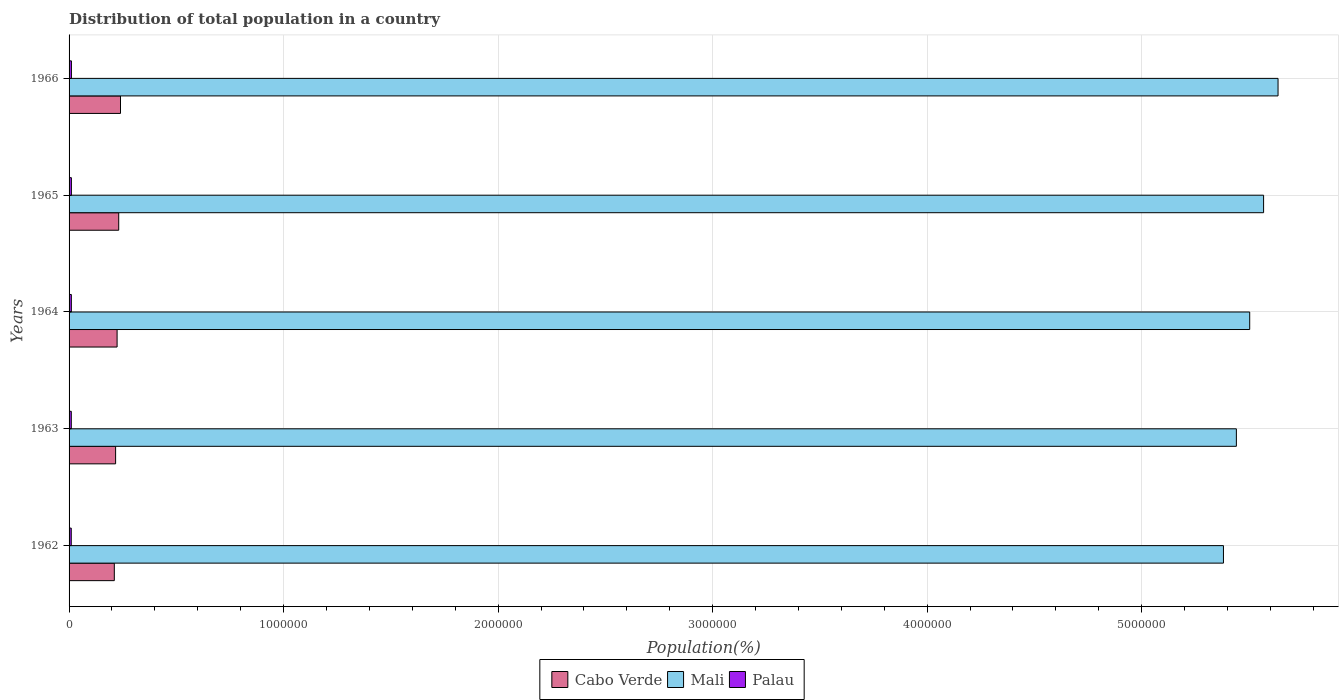How many different coloured bars are there?
Provide a succinct answer. 3. How many bars are there on the 4th tick from the top?
Provide a short and direct response. 3. What is the label of the 5th group of bars from the top?
Keep it short and to the point. 1962. What is the population of in Mali in 1964?
Ensure brevity in your answer.  5.50e+06. Across all years, what is the maximum population of in Mali?
Keep it short and to the point. 5.64e+06. Across all years, what is the minimum population of in Mali?
Give a very brief answer. 5.38e+06. In which year was the population of in Cabo Verde maximum?
Offer a terse response. 1966. In which year was the population of in Mali minimum?
Give a very brief answer. 1962. What is the total population of in Cabo Verde in the graph?
Offer a terse response. 1.12e+06. What is the difference between the population of in Mali in 1963 and that in 1965?
Give a very brief answer. -1.27e+05. What is the difference between the population of in Cabo Verde in 1964 and the population of in Mali in 1965?
Make the answer very short. -5.34e+06. What is the average population of in Cabo Verde per year?
Offer a very short reply. 2.25e+05. In the year 1964, what is the difference between the population of in Mali and population of in Palau?
Provide a short and direct response. 5.49e+06. What is the ratio of the population of in Cabo Verde in 1964 to that in 1965?
Your answer should be very brief. 0.97. What is the difference between the highest and the second highest population of in Cabo Verde?
Ensure brevity in your answer.  8338. What is the difference between the highest and the lowest population of in Palau?
Ensure brevity in your answer.  795. In how many years, is the population of in Palau greater than the average population of in Palau taken over all years?
Your answer should be very brief. 3. What does the 3rd bar from the top in 1965 represents?
Your response must be concise. Cabo Verde. What does the 3rd bar from the bottom in 1964 represents?
Your answer should be very brief. Palau. Are all the bars in the graph horizontal?
Your answer should be compact. Yes. What is the difference between two consecutive major ticks on the X-axis?
Make the answer very short. 1.00e+06. Are the values on the major ticks of X-axis written in scientific E-notation?
Make the answer very short. No. Does the graph contain grids?
Provide a short and direct response. Yes. Where does the legend appear in the graph?
Make the answer very short. Bottom center. How are the legend labels stacked?
Your answer should be very brief. Horizontal. What is the title of the graph?
Your response must be concise. Distribution of total population in a country. What is the label or title of the X-axis?
Provide a succinct answer. Population(%). What is the label or title of the Y-axis?
Your response must be concise. Years. What is the Population(%) of Cabo Verde in 1962?
Your answer should be very brief. 2.11e+05. What is the Population(%) of Mali in 1962?
Your response must be concise. 5.38e+06. What is the Population(%) in Palau in 1962?
Provide a short and direct response. 1.02e+04. What is the Population(%) in Cabo Verde in 1963?
Keep it short and to the point. 2.17e+05. What is the Population(%) in Mali in 1963?
Make the answer very short. 5.44e+06. What is the Population(%) of Palau in 1963?
Offer a terse response. 1.04e+04. What is the Population(%) in Cabo Verde in 1964?
Ensure brevity in your answer.  2.24e+05. What is the Population(%) in Mali in 1964?
Keep it short and to the point. 5.50e+06. What is the Population(%) of Palau in 1964?
Your answer should be compact. 1.06e+04. What is the Population(%) in Cabo Verde in 1965?
Your answer should be very brief. 2.31e+05. What is the Population(%) in Mali in 1965?
Provide a succinct answer. 5.57e+06. What is the Population(%) in Palau in 1965?
Provide a succinct answer. 1.08e+04. What is the Population(%) of Cabo Verde in 1966?
Make the answer very short. 2.40e+05. What is the Population(%) of Mali in 1966?
Keep it short and to the point. 5.64e+06. What is the Population(%) of Palau in 1966?
Offer a very short reply. 1.09e+04. Across all years, what is the maximum Population(%) in Cabo Verde?
Offer a terse response. 2.40e+05. Across all years, what is the maximum Population(%) in Mali?
Keep it short and to the point. 5.64e+06. Across all years, what is the maximum Population(%) of Palau?
Make the answer very short. 1.09e+04. Across all years, what is the minimum Population(%) in Cabo Verde?
Provide a succinct answer. 2.11e+05. Across all years, what is the minimum Population(%) of Mali?
Provide a short and direct response. 5.38e+06. Across all years, what is the minimum Population(%) in Palau?
Provide a succinct answer. 1.02e+04. What is the total Population(%) in Cabo Verde in the graph?
Provide a succinct answer. 1.12e+06. What is the total Population(%) of Mali in the graph?
Keep it short and to the point. 2.75e+07. What is the total Population(%) in Palau in the graph?
Provide a short and direct response. 5.29e+04. What is the difference between the Population(%) in Cabo Verde in 1962 and that in 1963?
Make the answer very short. -6047. What is the difference between the Population(%) in Mali in 1962 and that in 1963?
Offer a very short reply. -6.02e+04. What is the difference between the Population(%) in Palau in 1962 and that in 1963?
Provide a succinct answer. -231. What is the difference between the Population(%) of Cabo Verde in 1962 and that in 1964?
Offer a very short reply. -1.30e+04. What is the difference between the Population(%) in Mali in 1962 and that in 1964?
Offer a very short reply. -1.22e+05. What is the difference between the Population(%) of Palau in 1962 and that in 1964?
Offer a terse response. -443. What is the difference between the Population(%) in Cabo Verde in 1962 and that in 1965?
Provide a short and direct response. -2.06e+04. What is the difference between the Population(%) of Mali in 1962 and that in 1965?
Ensure brevity in your answer.  -1.87e+05. What is the difference between the Population(%) of Palau in 1962 and that in 1965?
Your response must be concise. -632. What is the difference between the Population(%) of Cabo Verde in 1962 and that in 1966?
Offer a very short reply. -2.89e+04. What is the difference between the Population(%) in Mali in 1962 and that in 1966?
Make the answer very short. -2.54e+05. What is the difference between the Population(%) of Palau in 1962 and that in 1966?
Your answer should be compact. -795. What is the difference between the Population(%) in Cabo Verde in 1963 and that in 1964?
Provide a short and direct response. -6941. What is the difference between the Population(%) of Mali in 1963 and that in 1964?
Offer a very short reply. -6.21e+04. What is the difference between the Population(%) of Palau in 1963 and that in 1964?
Give a very brief answer. -212. What is the difference between the Population(%) in Cabo Verde in 1963 and that in 1965?
Keep it short and to the point. -1.45e+04. What is the difference between the Population(%) in Mali in 1963 and that in 1965?
Offer a terse response. -1.27e+05. What is the difference between the Population(%) in Palau in 1963 and that in 1965?
Offer a very short reply. -401. What is the difference between the Population(%) of Cabo Verde in 1963 and that in 1966?
Ensure brevity in your answer.  -2.29e+04. What is the difference between the Population(%) in Mali in 1963 and that in 1966?
Keep it short and to the point. -1.94e+05. What is the difference between the Population(%) of Palau in 1963 and that in 1966?
Your response must be concise. -564. What is the difference between the Population(%) of Cabo Verde in 1964 and that in 1965?
Give a very brief answer. -7573. What is the difference between the Population(%) in Mali in 1964 and that in 1965?
Provide a short and direct response. -6.47e+04. What is the difference between the Population(%) of Palau in 1964 and that in 1965?
Give a very brief answer. -189. What is the difference between the Population(%) of Cabo Verde in 1964 and that in 1966?
Offer a very short reply. -1.59e+04. What is the difference between the Population(%) of Mali in 1964 and that in 1966?
Give a very brief answer. -1.32e+05. What is the difference between the Population(%) in Palau in 1964 and that in 1966?
Ensure brevity in your answer.  -352. What is the difference between the Population(%) in Cabo Verde in 1965 and that in 1966?
Provide a succinct answer. -8338. What is the difference between the Population(%) in Mali in 1965 and that in 1966?
Your answer should be compact. -6.74e+04. What is the difference between the Population(%) in Palau in 1965 and that in 1966?
Ensure brevity in your answer.  -163. What is the difference between the Population(%) of Cabo Verde in 1962 and the Population(%) of Mali in 1963?
Your answer should be compact. -5.23e+06. What is the difference between the Population(%) in Cabo Verde in 1962 and the Population(%) in Palau in 1963?
Ensure brevity in your answer.  2.00e+05. What is the difference between the Population(%) of Mali in 1962 and the Population(%) of Palau in 1963?
Your answer should be very brief. 5.37e+06. What is the difference between the Population(%) in Cabo Verde in 1962 and the Population(%) in Mali in 1964?
Ensure brevity in your answer.  -5.29e+06. What is the difference between the Population(%) in Cabo Verde in 1962 and the Population(%) in Palau in 1964?
Your response must be concise. 2.00e+05. What is the difference between the Population(%) of Mali in 1962 and the Population(%) of Palau in 1964?
Your answer should be very brief. 5.37e+06. What is the difference between the Population(%) of Cabo Verde in 1962 and the Population(%) of Mali in 1965?
Offer a very short reply. -5.36e+06. What is the difference between the Population(%) in Cabo Verde in 1962 and the Population(%) in Palau in 1965?
Ensure brevity in your answer.  2.00e+05. What is the difference between the Population(%) in Mali in 1962 and the Population(%) in Palau in 1965?
Provide a short and direct response. 5.37e+06. What is the difference between the Population(%) in Cabo Verde in 1962 and the Population(%) in Mali in 1966?
Your response must be concise. -5.42e+06. What is the difference between the Population(%) of Cabo Verde in 1962 and the Population(%) of Palau in 1966?
Offer a very short reply. 2.00e+05. What is the difference between the Population(%) in Mali in 1962 and the Population(%) in Palau in 1966?
Give a very brief answer. 5.37e+06. What is the difference between the Population(%) in Cabo Verde in 1963 and the Population(%) in Mali in 1964?
Ensure brevity in your answer.  -5.29e+06. What is the difference between the Population(%) in Cabo Verde in 1963 and the Population(%) in Palau in 1964?
Offer a terse response. 2.06e+05. What is the difference between the Population(%) of Mali in 1963 and the Population(%) of Palau in 1964?
Keep it short and to the point. 5.43e+06. What is the difference between the Population(%) in Cabo Verde in 1963 and the Population(%) in Mali in 1965?
Your answer should be very brief. -5.35e+06. What is the difference between the Population(%) of Cabo Verde in 1963 and the Population(%) of Palau in 1965?
Give a very brief answer. 2.06e+05. What is the difference between the Population(%) in Mali in 1963 and the Population(%) in Palau in 1965?
Offer a terse response. 5.43e+06. What is the difference between the Population(%) in Cabo Verde in 1963 and the Population(%) in Mali in 1966?
Your answer should be compact. -5.42e+06. What is the difference between the Population(%) of Cabo Verde in 1963 and the Population(%) of Palau in 1966?
Provide a succinct answer. 2.06e+05. What is the difference between the Population(%) in Mali in 1963 and the Population(%) in Palau in 1966?
Keep it short and to the point. 5.43e+06. What is the difference between the Population(%) in Cabo Verde in 1964 and the Population(%) in Mali in 1965?
Keep it short and to the point. -5.34e+06. What is the difference between the Population(%) in Cabo Verde in 1964 and the Population(%) in Palau in 1965?
Offer a terse response. 2.13e+05. What is the difference between the Population(%) in Mali in 1964 and the Population(%) in Palau in 1965?
Give a very brief answer. 5.49e+06. What is the difference between the Population(%) in Cabo Verde in 1964 and the Population(%) in Mali in 1966?
Make the answer very short. -5.41e+06. What is the difference between the Population(%) in Cabo Verde in 1964 and the Population(%) in Palau in 1966?
Provide a short and direct response. 2.13e+05. What is the difference between the Population(%) of Mali in 1964 and the Population(%) of Palau in 1966?
Provide a succinct answer. 5.49e+06. What is the difference between the Population(%) in Cabo Verde in 1965 and the Population(%) in Mali in 1966?
Give a very brief answer. -5.40e+06. What is the difference between the Population(%) in Cabo Verde in 1965 and the Population(%) in Palau in 1966?
Your answer should be very brief. 2.20e+05. What is the difference between the Population(%) of Mali in 1965 and the Population(%) of Palau in 1966?
Ensure brevity in your answer.  5.56e+06. What is the average Population(%) in Cabo Verde per year?
Your answer should be very brief. 2.25e+05. What is the average Population(%) in Mali per year?
Provide a succinct answer. 5.51e+06. What is the average Population(%) in Palau per year?
Provide a short and direct response. 1.06e+04. In the year 1962, what is the difference between the Population(%) in Cabo Verde and Population(%) in Mali?
Your response must be concise. -5.17e+06. In the year 1962, what is the difference between the Population(%) in Cabo Verde and Population(%) in Palau?
Your response must be concise. 2.01e+05. In the year 1962, what is the difference between the Population(%) in Mali and Population(%) in Palau?
Your answer should be compact. 5.37e+06. In the year 1963, what is the difference between the Population(%) of Cabo Verde and Population(%) of Mali?
Your response must be concise. -5.22e+06. In the year 1963, what is the difference between the Population(%) of Cabo Verde and Population(%) of Palau?
Provide a short and direct response. 2.07e+05. In the year 1963, what is the difference between the Population(%) of Mali and Population(%) of Palau?
Your answer should be compact. 5.43e+06. In the year 1964, what is the difference between the Population(%) of Cabo Verde and Population(%) of Mali?
Keep it short and to the point. -5.28e+06. In the year 1964, what is the difference between the Population(%) of Cabo Verde and Population(%) of Palau?
Your answer should be very brief. 2.13e+05. In the year 1964, what is the difference between the Population(%) of Mali and Population(%) of Palau?
Give a very brief answer. 5.49e+06. In the year 1965, what is the difference between the Population(%) in Cabo Verde and Population(%) in Mali?
Provide a succinct answer. -5.34e+06. In the year 1965, what is the difference between the Population(%) of Cabo Verde and Population(%) of Palau?
Offer a terse response. 2.21e+05. In the year 1965, what is the difference between the Population(%) in Mali and Population(%) in Palau?
Provide a succinct answer. 5.56e+06. In the year 1966, what is the difference between the Population(%) in Cabo Verde and Population(%) in Mali?
Your answer should be compact. -5.40e+06. In the year 1966, what is the difference between the Population(%) in Cabo Verde and Population(%) in Palau?
Ensure brevity in your answer.  2.29e+05. In the year 1966, what is the difference between the Population(%) in Mali and Population(%) in Palau?
Keep it short and to the point. 5.62e+06. What is the ratio of the Population(%) of Cabo Verde in 1962 to that in 1963?
Your response must be concise. 0.97. What is the ratio of the Population(%) of Mali in 1962 to that in 1963?
Keep it short and to the point. 0.99. What is the ratio of the Population(%) of Palau in 1962 to that in 1963?
Give a very brief answer. 0.98. What is the ratio of the Population(%) in Cabo Verde in 1962 to that in 1964?
Make the answer very short. 0.94. What is the ratio of the Population(%) in Mali in 1962 to that in 1964?
Provide a succinct answer. 0.98. What is the ratio of the Population(%) in Palau in 1962 to that in 1964?
Give a very brief answer. 0.96. What is the ratio of the Population(%) of Cabo Verde in 1962 to that in 1965?
Make the answer very short. 0.91. What is the ratio of the Population(%) of Mali in 1962 to that in 1965?
Provide a succinct answer. 0.97. What is the ratio of the Population(%) in Palau in 1962 to that in 1965?
Your answer should be very brief. 0.94. What is the ratio of the Population(%) in Cabo Verde in 1962 to that in 1966?
Offer a terse response. 0.88. What is the ratio of the Population(%) of Mali in 1962 to that in 1966?
Provide a short and direct response. 0.95. What is the ratio of the Population(%) in Palau in 1962 to that in 1966?
Offer a terse response. 0.93. What is the ratio of the Population(%) of Mali in 1963 to that in 1964?
Provide a succinct answer. 0.99. What is the ratio of the Population(%) in Palau in 1963 to that in 1964?
Your answer should be compact. 0.98. What is the ratio of the Population(%) of Cabo Verde in 1963 to that in 1965?
Keep it short and to the point. 0.94. What is the ratio of the Population(%) in Mali in 1963 to that in 1965?
Your answer should be compact. 0.98. What is the ratio of the Population(%) of Palau in 1963 to that in 1965?
Keep it short and to the point. 0.96. What is the ratio of the Population(%) of Cabo Verde in 1963 to that in 1966?
Your response must be concise. 0.9. What is the ratio of the Population(%) in Mali in 1963 to that in 1966?
Your response must be concise. 0.97. What is the ratio of the Population(%) of Palau in 1963 to that in 1966?
Provide a short and direct response. 0.95. What is the ratio of the Population(%) in Cabo Verde in 1964 to that in 1965?
Provide a succinct answer. 0.97. What is the ratio of the Population(%) in Mali in 1964 to that in 1965?
Offer a terse response. 0.99. What is the ratio of the Population(%) in Palau in 1964 to that in 1965?
Your response must be concise. 0.98. What is the ratio of the Population(%) of Cabo Verde in 1964 to that in 1966?
Your response must be concise. 0.93. What is the ratio of the Population(%) in Mali in 1964 to that in 1966?
Your response must be concise. 0.98. What is the ratio of the Population(%) in Palau in 1964 to that in 1966?
Provide a succinct answer. 0.97. What is the ratio of the Population(%) in Cabo Verde in 1965 to that in 1966?
Your response must be concise. 0.97. What is the ratio of the Population(%) of Palau in 1965 to that in 1966?
Your response must be concise. 0.99. What is the difference between the highest and the second highest Population(%) of Cabo Verde?
Provide a short and direct response. 8338. What is the difference between the highest and the second highest Population(%) of Mali?
Provide a short and direct response. 6.74e+04. What is the difference between the highest and the second highest Population(%) of Palau?
Your answer should be very brief. 163. What is the difference between the highest and the lowest Population(%) in Cabo Verde?
Your answer should be very brief. 2.89e+04. What is the difference between the highest and the lowest Population(%) of Mali?
Provide a succinct answer. 2.54e+05. What is the difference between the highest and the lowest Population(%) in Palau?
Make the answer very short. 795. 